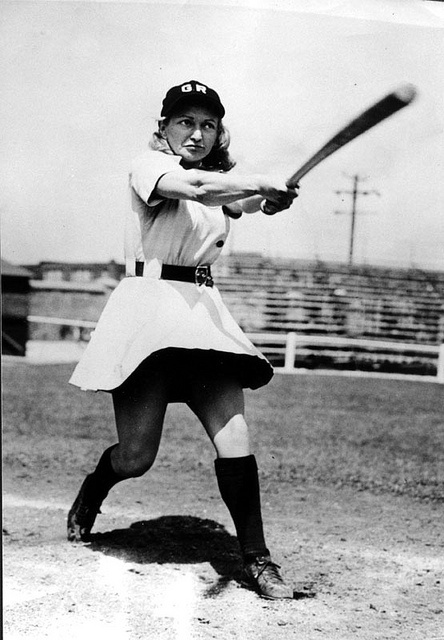Describe the objects in this image and their specific colors. I can see people in lightgray, black, darkgray, and gray tones and baseball bat in lightgray, black, gray, and darkgray tones in this image. 